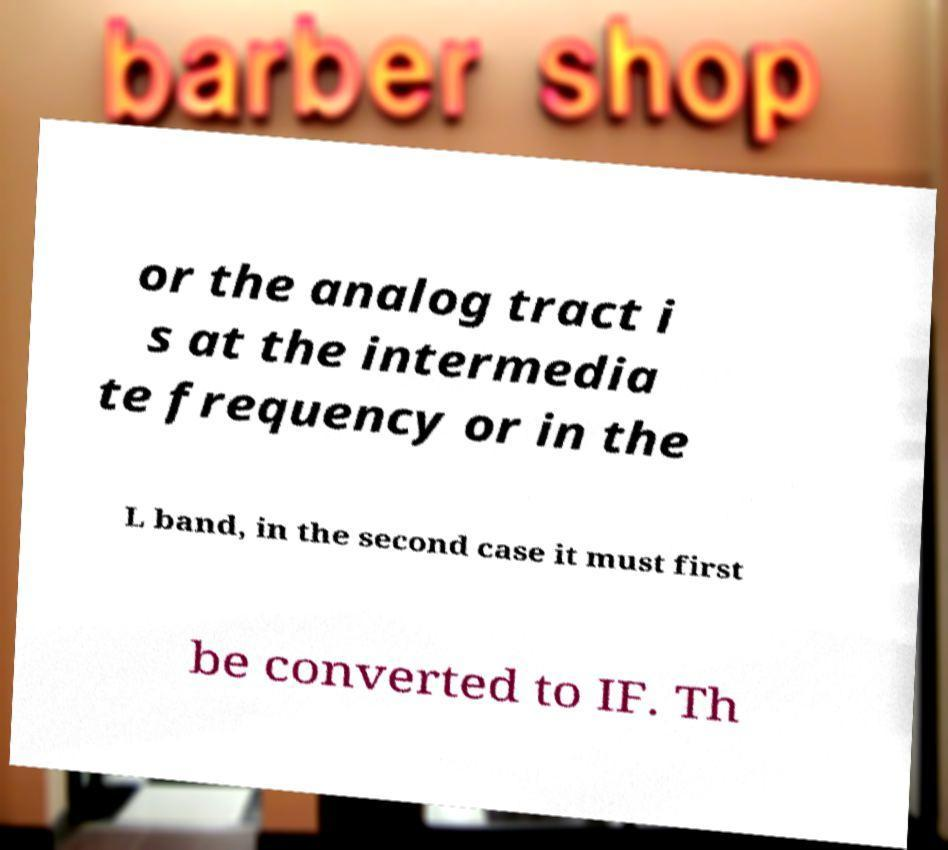What messages or text are displayed in this image? I need them in a readable, typed format. or the analog tract i s at the intermedia te frequency or in the L band, in the second case it must first be converted to IF. Th 